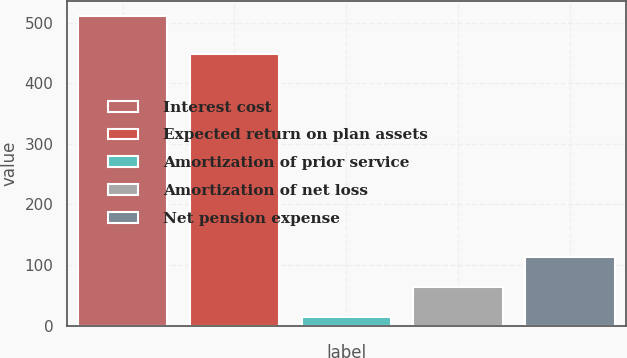Convert chart. <chart><loc_0><loc_0><loc_500><loc_500><bar_chart><fcel>Interest cost<fcel>Expected return on plan assets<fcel>Amortization of prior service<fcel>Amortization of net loss<fcel>Net pension expense<nl><fcel>511<fcel>448<fcel>14<fcel>63.7<fcel>113.4<nl></chart> 